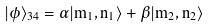<formula> <loc_0><loc_0><loc_500><loc_500>| \phi \rangle _ { 3 4 } = \alpha | m _ { 1 } , n _ { 1 } \rangle + \beta | m _ { 2 } , n _ { 2 } \rangle</formula> 